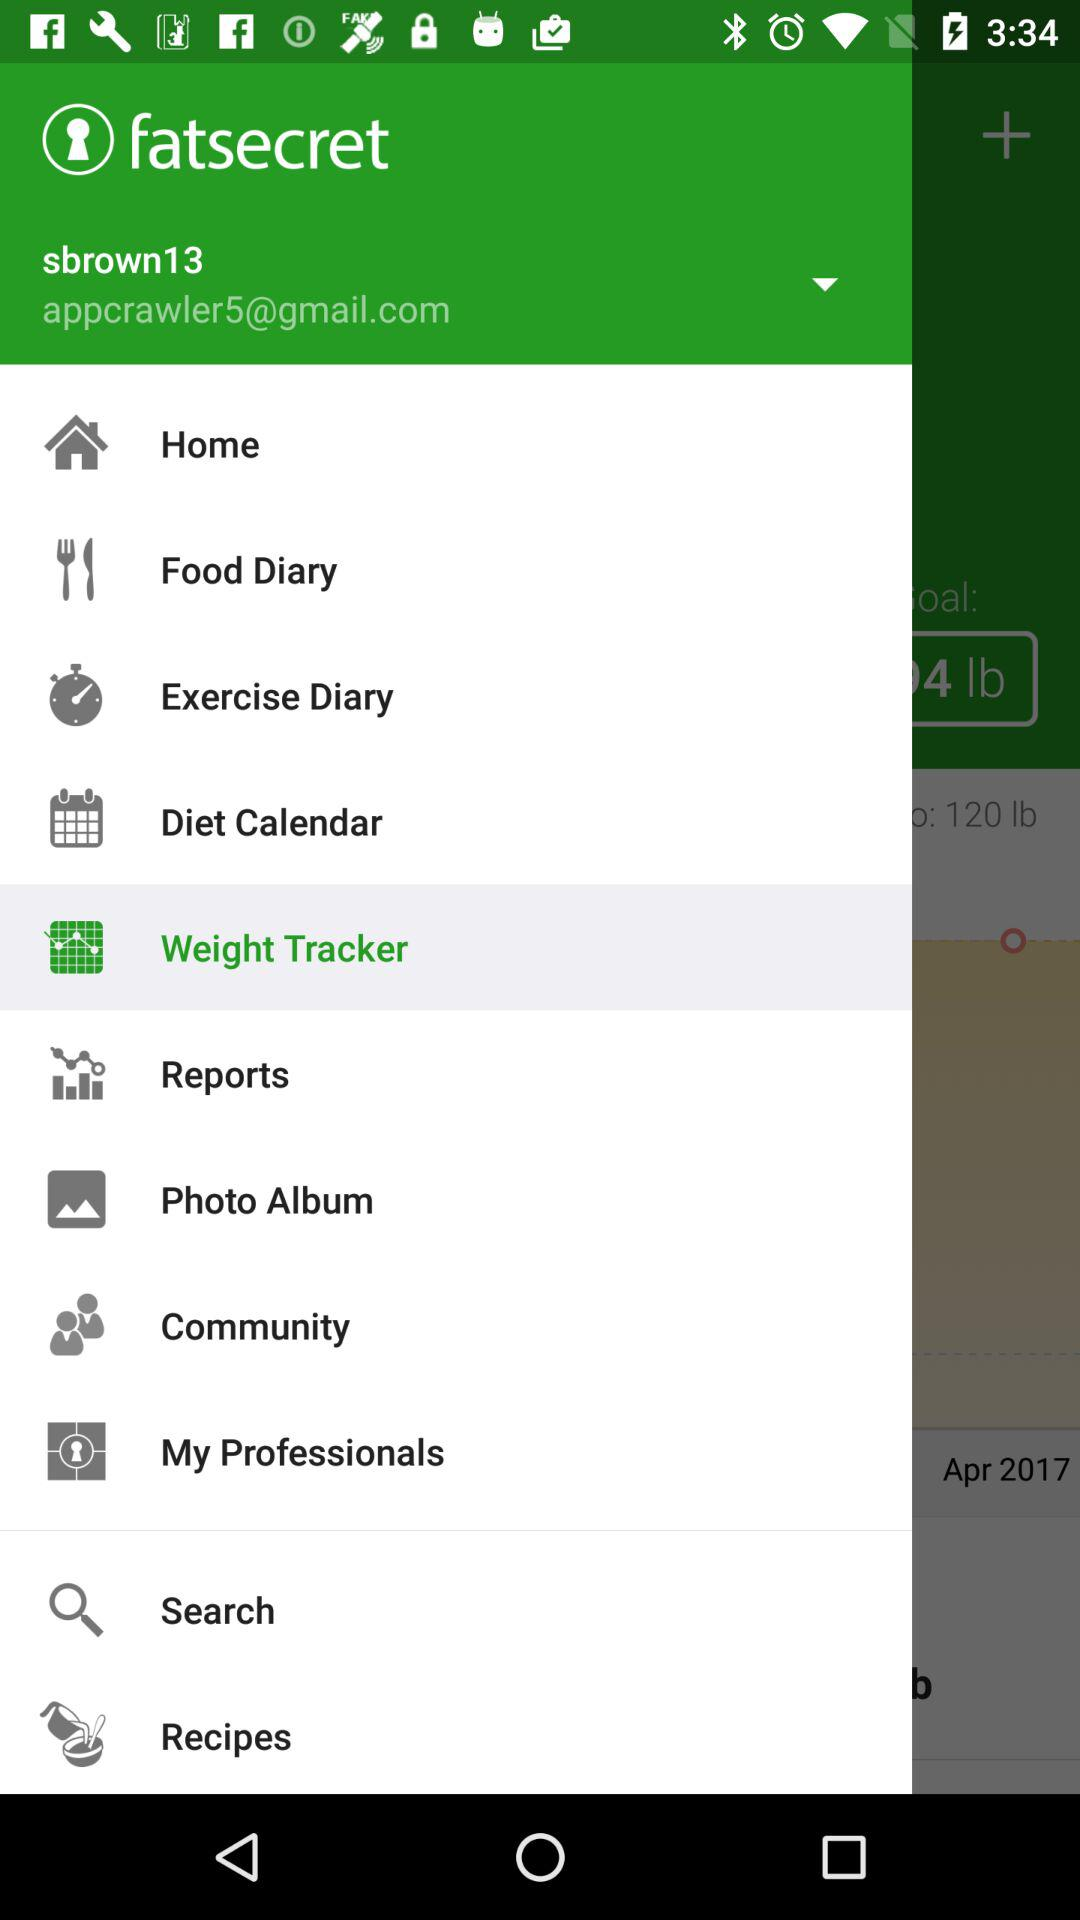Which item is selected in the menu? The selected item is "Weight Tracker". 